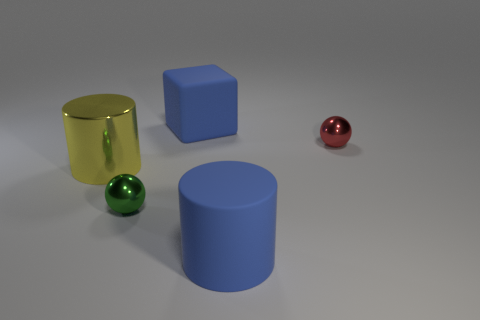The tiny green object that is the same material as the yellow thing is what shape?
Offer a terse response. Sphere. Are there fewer tiny spheres that are behind the blue rubber cube than large rubber objects in front of the big shiny thing?
Provide a short and direct response. Yes. How many large objects are matte cylinders or green metal balls?
Provide a succinct answer. 1. There is a metal object that is to the left of the green ball; is its shape the same as the rubber thing in front of the red sphere?
Make the answer very short. Yes. There is a metallic object that is in front of the shiny object left of the small green metallic sphere in front of the yellow thing; how big is it?
Your response must be concise. Small. There is a shiny sphere that is in front of the big metal cylinder; how big is it?
Make the answer very short. Small. What material is the cylinder behind the green thing?
Provide a succinct answer. Metal. What number of red objects are either small things or large matte objects?
Keep it short and to the point. 1. Does the small red sphere have the same material as the tiny sphere to the left of the red object?
Provide a short and direct response. Yes. Is the number of blocks that are behind the big blue matte block the same as the number of tiny green metal objects that are to the left of the yellow object?
Provide a succinct answer. Yes. 